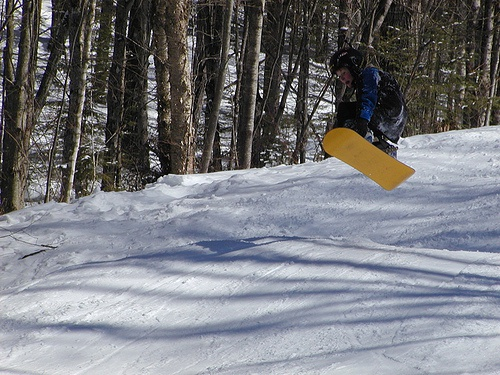Describe the objects in this image and their specific colors. I can see people in gray, black, and navy tones and snowboard in gray, olive, and tan tones in this image. 